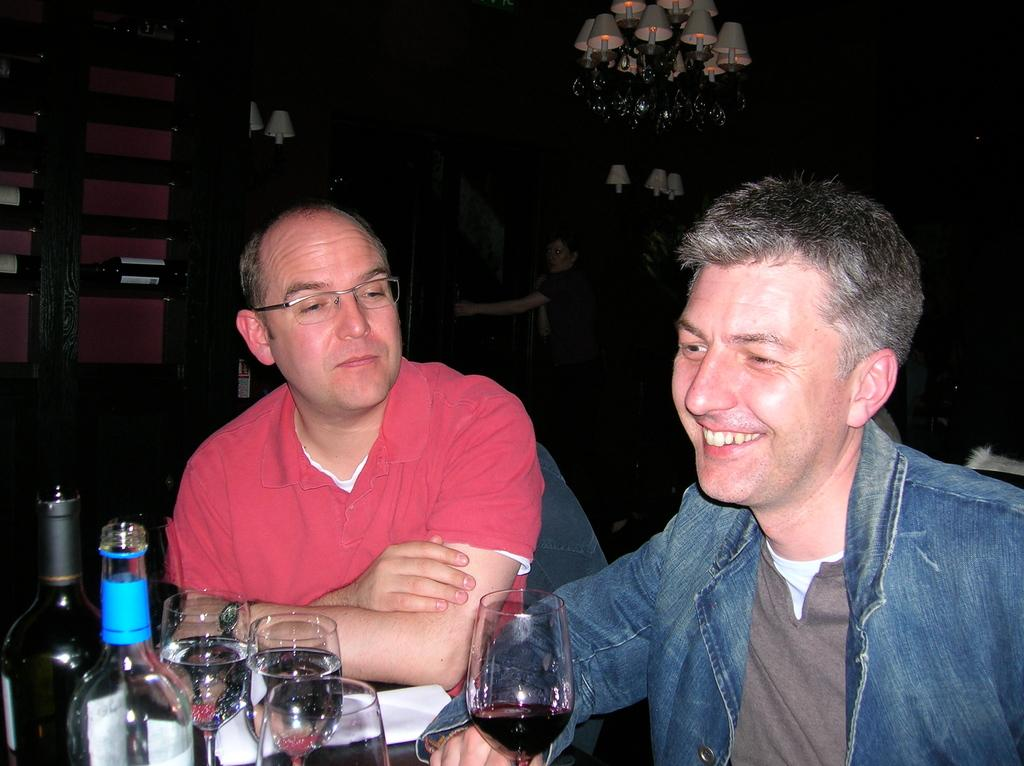What is the man in the red t-shirt wearing in the image? The man in the red t-shirt is wearing spectacles. What is the color of the jacket worn by the other man in the image? The man in the blue jacket is wearing a blue jacket. What is the facial expression of the man in the blue jacket? The man in the blue jacket is smiling. What objects can be seen on the table in the image? There is a paper, a glass, and wine bottles on the table. What type of cough can be heard in the image? There is no sound, including coughing, present in the image. What line is being drawn in the image? There is no line being drawn in the image. 